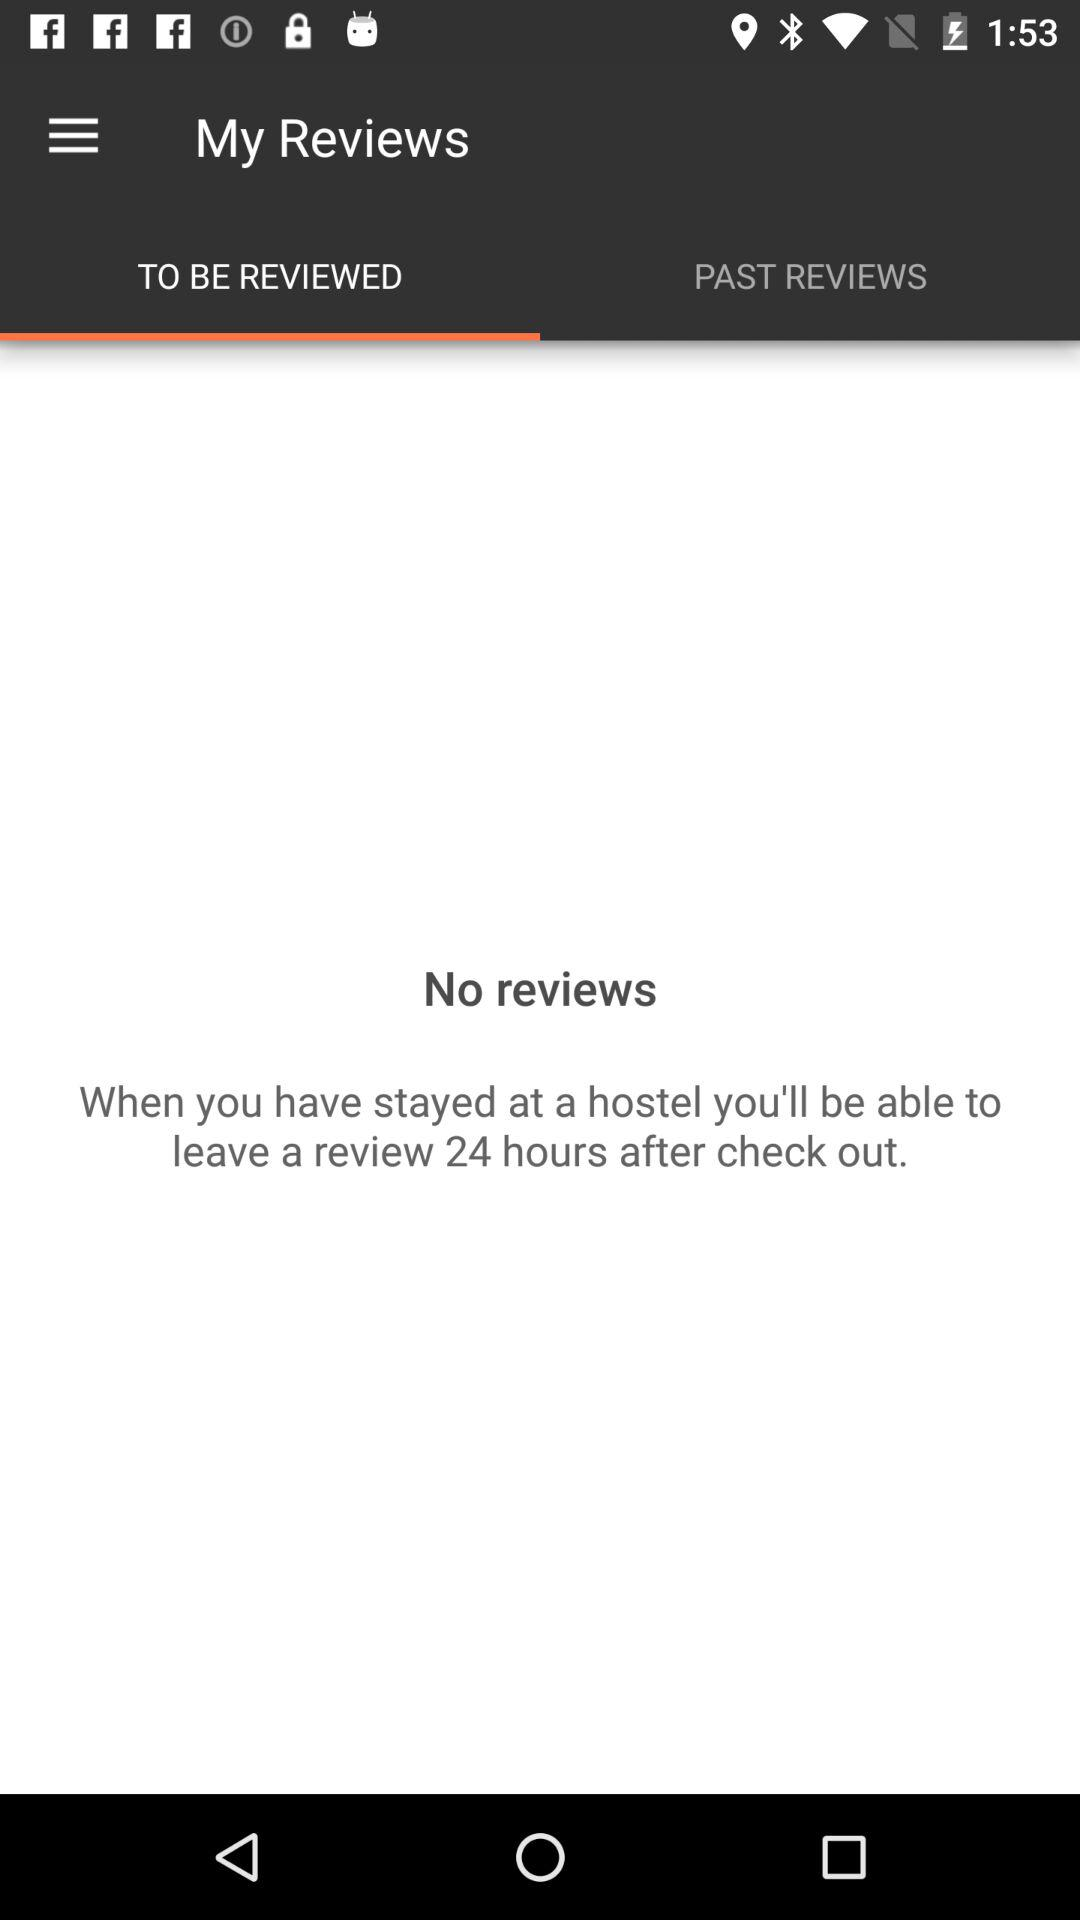How many hours after check out can I leave a review?
Answer the question using a single word or phrase. 24 